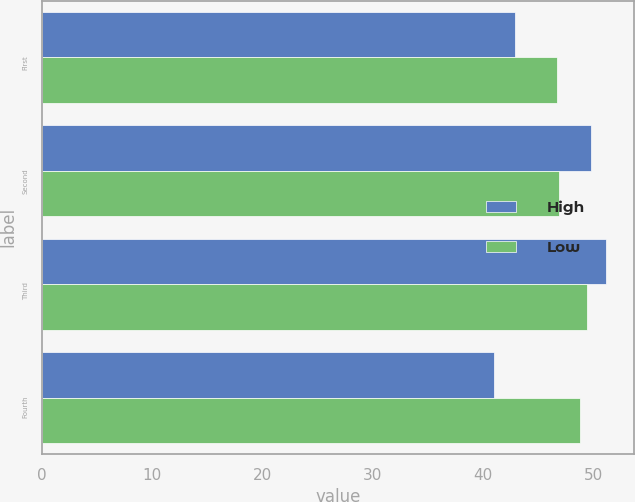<chart> <loc_0><loc_0><loc_500><loc_500><stacked_bar_chart><ecel><fcel>First<fcel>Second<fcel>Third<fcel>Fourth<nl><fcel>High<fcel>42.9<fcel>49.76<fcel>51.1<fcel>41<nl><fcel>Low<fcel>46.71<fcel>46.85<fcel>49.37<fcel>48.78<nl></chart> 